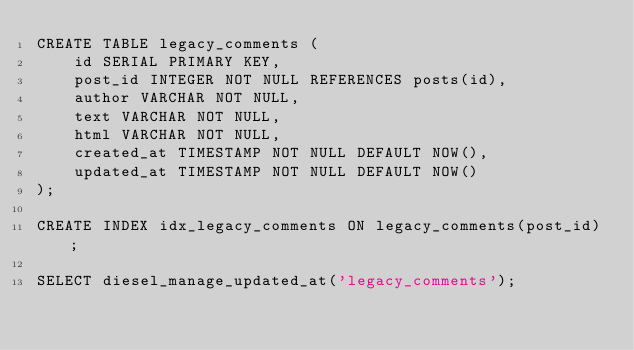Convert code to text. <code><loc_0><loc_0><loc_500><loc_500><_SQL_>CREATE TABLE legacy_comments (
    id SERIAL PRIMARY KEY,
    post_id INTEGER NOT NULL REFERENCES posts(id),
    author VARCHAR NOT NULL,
    text VARCHAR NOT NULL,
    html VARCHAR NOT NULL,
    created_at TIMESTAMP NOT NULL DEFAULT NOW(),
    updated_at TIMESTAMP NOT NULL DEFAULT NOW()
);

CREATE INDEX idx_legacy_comments ON legacy_comments(post_id);

SELECT diesel_manage_updated_at('legacy_comments');
</code> 